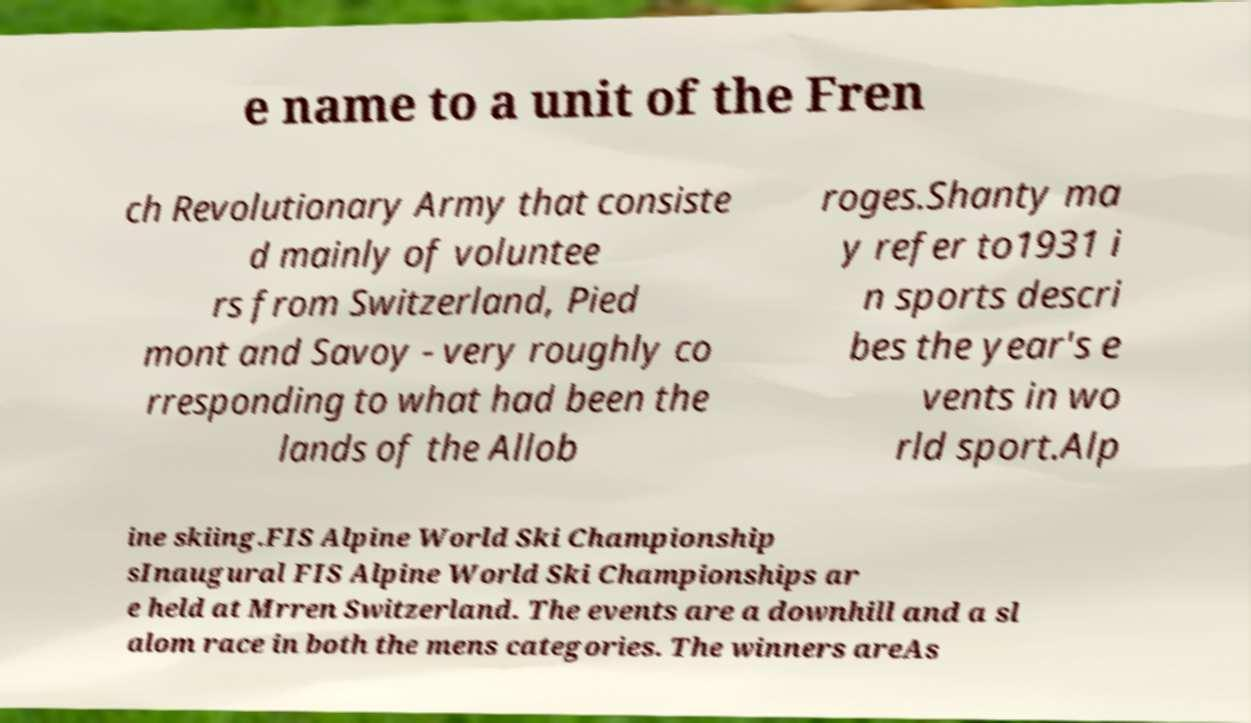Could you assist in decoding the text presented in this image and type it out clearly? e name to a unit of the Fren ch Revolutionary Army that consiste d mainly of voluntee rs from Switzerland, Pied mont and Savoy - very roughly co rresponding to what had been the lands of the Allob roges.Shanty ma y refer to1931 i n sports descri bes the year's e vents in wo rld sport.Alp ine skiing.FIS Alpine World Ski Championship sInaugural FIS Alpine World Ski Championships ar e held at Mrren Switzerland. The events are a downhill and a sl alom race in both the mens categories. The winners areAs 